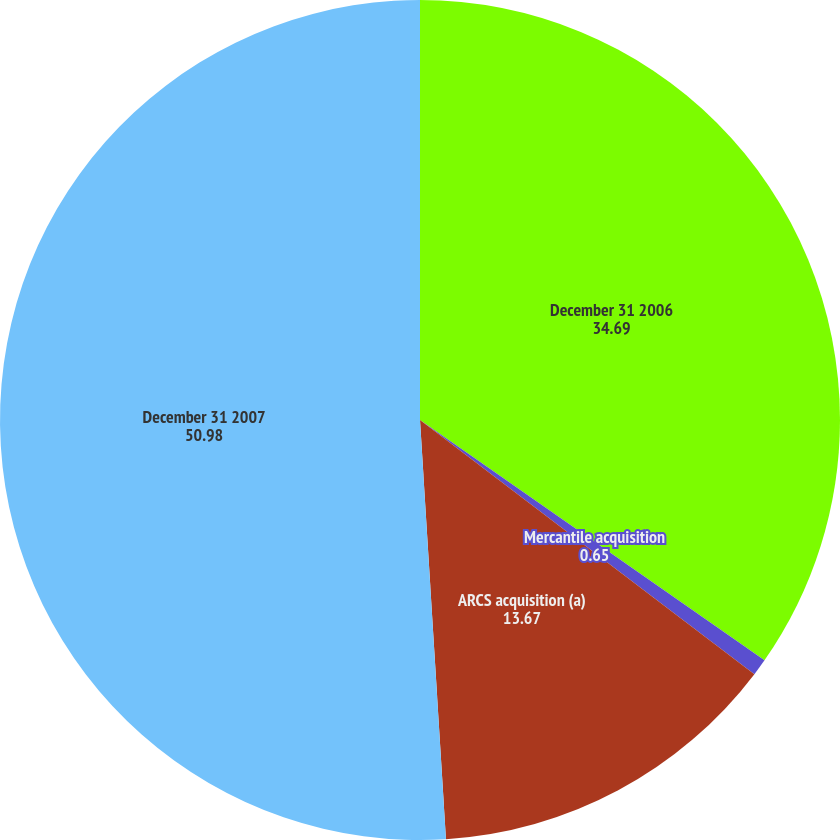Convert chart. <chart><loc_0><loc_0><loc_500><loc_500><pie_chart><fcel>December 31 2006<fcel>Mercantile acquisition<fcel>ARCS acquisition (a)<fcel>December 31 2007<nl><fcel>34.69%<fcel>0.65%<fcel>13.67%<fcel>50.98%<nl></chart> 